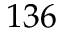Convert formula to latex. <formula><loc_0><loc_0><loc_500><loc_500>1 3 6</formula> 